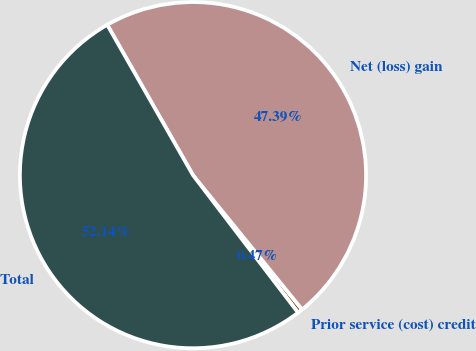<chart> <loc_0><loc_0><loc_500><loc_500><pie_chart><fcel>Prior service (cost) credit<fcel>Net (loss) gain<fcel>Total<nl><fcel>0.47%<fcel>47.39%<fcel>52.13%<nl></chart> 